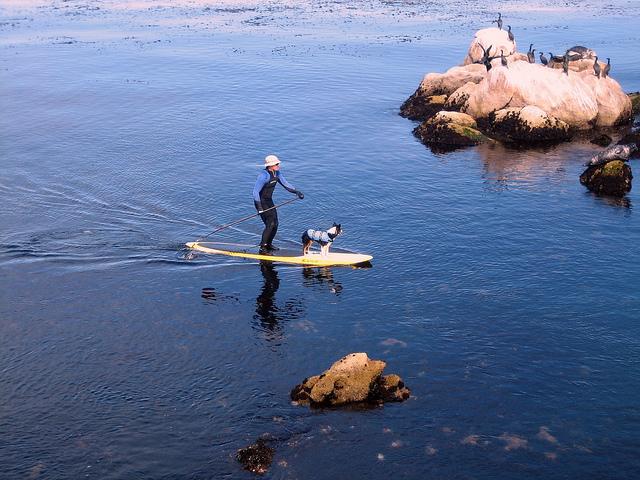What color is the water?
Write a very short answer. Blue. What animals are all over the rocks?
Concise answer only. Birds. What animal stands in front of the man on the board?
Quick response, please. Dog. 